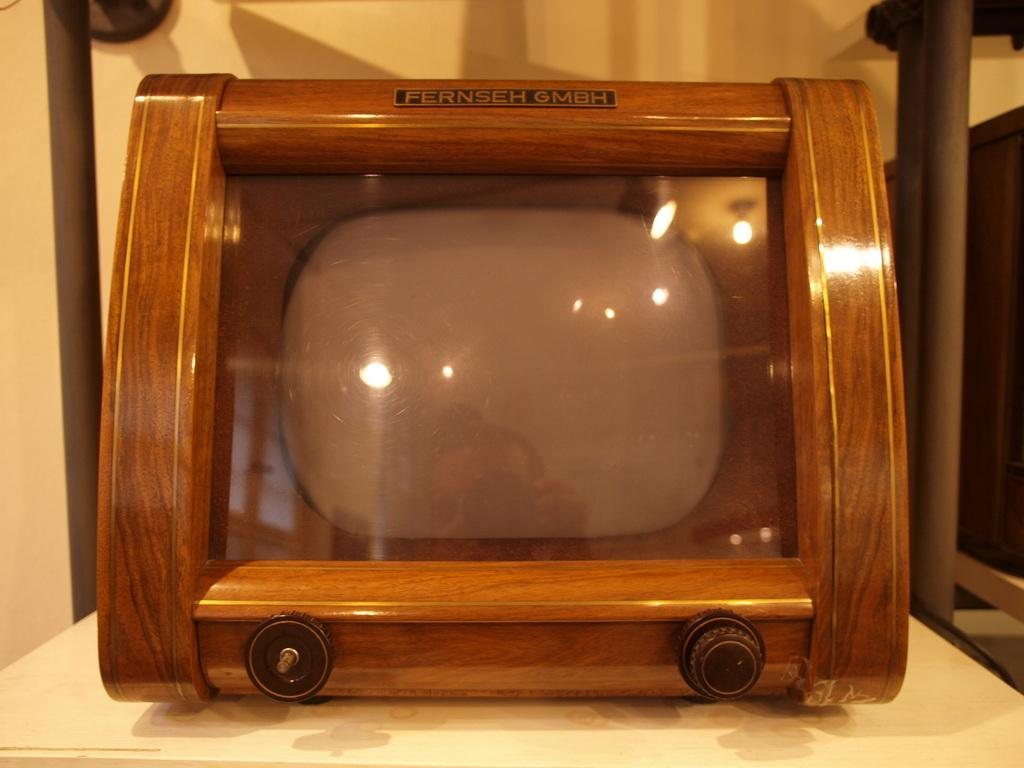What is placed on the table in the image? There is an object placed on a table in the image, but the specific object is not mentioned in the facts. What can be seen in the background of the image? There is a wall and a stand in the background of the image. Can you describe the setting of the image? The image shows an object placed on a table with a wall and a stand in the background. What type of weather can be seen in the image? The facts provided do not mention any weather conditions, so it is not possible to determine the weather from the image. Is the grandmother present in the image? There is no mention of a grandmother or any people in the image, so it is not possible to determine if a grandmother is present. 